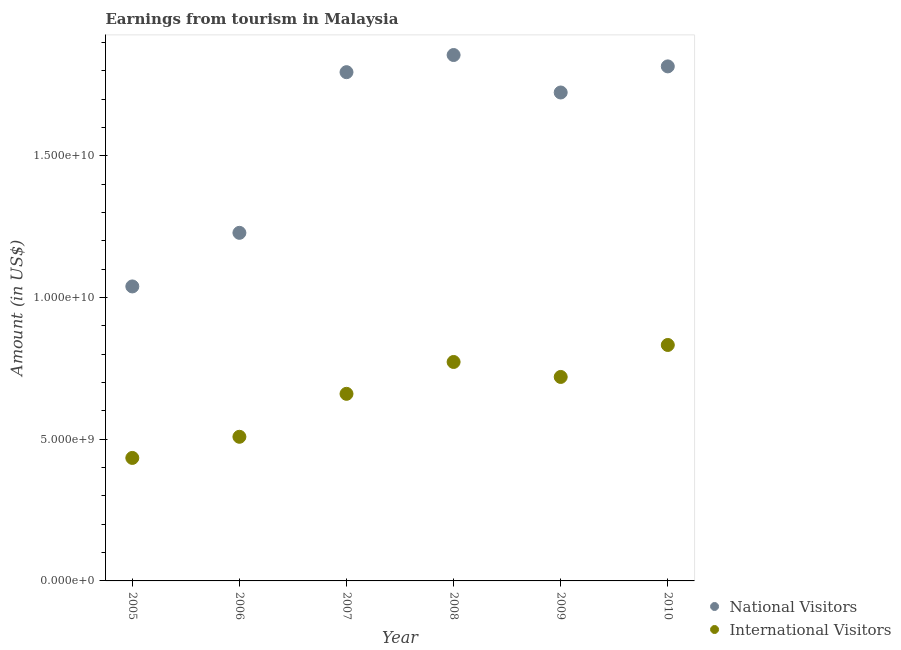How many different coloured dotlines are there?
Keep it short and to the point. 2. What is the amount earned from national visitors in 2007?
Your answer should be very brief. 1.79e+1. Across all years, what is the maximum amount earned from national visitors?
Your answer should be very brief. 1.86e+1. Across all years, what is the minimum amount earned from international visitors?
Offer a terse response. 4.34e+09. In which year was the amount earned from international visitors minimum?
Your answer should be very brief. 2005. What is the total amount earned from international visitors in the graph?
Your answer should be compact. 3.93e+1. What is the difference between the amount earned from international visitors in 2006 and that in 2009?
Provide a succinct answer. -2.11e+09. What is the difference between the amount earned from international visitors in 2007 and the amount earned from national visitors in 2009?
Your answer should be compact. -1.06e+1. What is the average amount earned from international visitors per year?
Offer a terse response. 6.54e+09. In the year 2010, what is the difference between the amount earned from international visitors and amount earned from national visitors?
Keep it short and to the point. -9.83e+09. In how many years, is the amount earned from international visitors greater than 14000000000 US$?
Make the answer very short. 0. What is the ratio of the amount earned from international visitors in 2005 to that in 2006?
Offer a very short reply. 0.85. Is the amount earned from international visitors in 2006 less than that in 2010?
Provide a succinct answer. Yes. What is the difference between the highest and the second highest amount earned from international visitors?
Your answer should be very brief. 6.00e+08. What is the difference between the highest and the lowest amount earned from national visitors?
Provide a succinct answer. 8.16e+09. In how many years, is the amount earned from international visitors greater than the average amount earned from international visitors taken over all years?
Offer a very short reply. 4. Is the sum of the amount earned from international visitors in 2005 and 2009 greater than the maximum amount earned from national visitors across all years?
Offer a terse response. No. Is the amount earned from international visitors strictly greater than the amount earned from national visitors over the years?
Make the answer very short. No. Is the amount earned from international visitors strictly less than the amount earned from national visitors over the years?
Your response must be concise. Yes. What is the difference between two consecutive major ticks on the Y-axis?
Your answer should be very brief. 5.00e+09. What is the title of the graph?
Offer a very short reply. Earnings from tourism in Malaysia. What is the label or title of the Y-axis?
Offer a terse response. Amount (in US$). What is the Amount (in US$) of National Visitors in 2005?
Your answer should be compact. 1.04e+1. What is the Amount (in US$) of International Visitors in 2005?
Offer a very short reply. 4.34e+09. What is the Amount (in US$) in National Visitors in 2006?
Offer a terse response. 1.23e+1. What is the Amount (in US$) in International Visitors in 2006?
Offer a terse response. 5.08e+09. What is the Amount (in US$) in National Visitors in 2007?
Your response must be concise. 1.79e+1. What is the Amount (in US$) of International Visitors in 2007?
Provide a short and direct response. 6.60e+09. What is the Amount (in US$) in National Visitors in 2008?
Give a very brief answer. 1.86e+1. What is the Amount (in US$) in International Visitors in 2008?
Give a very brief answer. 7.72e+09. What is the Amount (in US$) in National Visitors in 2009?
Offer a terse response. 1.72e+1. What is the Amount (in US$) in International Visitors in 2009?
Your answer should be compact. 7.20e+09. What is the Amount (in US$) of National Visitors in 2010?
Keep it short and to the point. 1.82e+1. What is the Amount (in US$) of International Visitors in 2010?
Ensure brevity in your answer.  8.32e+09. Across all years, what is the maximum Amount (in US$) in National Visitors?
Provide a short and direct response. 1.86e+1. Across all years, what is the maximum Amount (in US$) in International Visitors?
Your response must be concise. 8.32e+09. Across all years, what is the minimum Amount (in US$) in National Visitors?
Make the answer very short. 1.04e+1. Across all years, what is the minimum Amount (in US$) of International Visitors?
Ensure brevity in your answer.  4.34e+09. What is the total Amount (in US$) of National Visitors in the graph?
Offer a terse response. 9.46e+1. What is the total Amount (in US$) in International Visitors in the graph?
Give a very brief answer. 3.93e+1. What is the difference between the Amount (in US$) of National Visitors in 2005 and that in 2006?
Ensure brevity in your answer.  -1.89e+09. What is the difference between the Amount (in US$) in International Visitors in 2005 and that in 2006?
Make the answer very short. -7.46e+08. What is the difference between the Amount (in US$) in National Visitors in 2005 and that in 2007?
Provide a short and direct response. -7.56e+09. What is the difference between the Amount (in US$) in International Visitors in 2005 and that in 2007?
Offer a very short reply. -2.26e+09. What is the difference between the Amount (in US$) in National Visitors in 2005 and that in 2008?
Offer a very short reply. -8.16e+09. What is the difference between the Amount (in US$) of International Visitors in 2005 and that in 2008?
Keep it short and to the point. -3.38e+09. What is the difference between the Amount (in US$) of National Visitors in 2005 and that in 2009?
Provide a succinct answer. -6.84e+09. What is the difference between the Amount (in US$) of International Visitors in 2005 and that in 2009?
Offer a terse response. -2.86e+09. What is the difference between the Amount (in US$) in National Visitors in 2005 and that in 2010?
Your answer should be compact. -7.76e+09. What is the difference between the Amount (in US$) in International Visitors in 2005 and that in 2010?
Your response must be concise. -3.98e+09. What is the difference between the Amount (in US$) of National Visitors in 2006 and that in 2007?
Make the answer very short. -5.67e+09. What is the difference between the Amount (in US$) of International Visitors in 2006 and that in 2007?
Provide a succinct answer. -1.52e+09. What is the difference between the Amount (in US$) in National Visitors in 2006 and that in 2008?
Your response must be concise. -6.27e+09. What is the difference between the Amount (in US$) in International Visitors in 2006 and that in 2008?
Your answer should be compact. -2.64e+09. What is the difference between the Amount (in US$) of National Visitors in 2006 and that in 2009?
Provide a succinct answer. -4.95e+09. What is the difference between the Amount (in US$) in International Visitors in 2006 and that in 2009?
Your answer should be compact. -2.11e+09. What is the difference between the Amount (in US$) in National Visitors in 2006 and that in 2010?
Make the answer very short. -5.87e+09. What is the difference between the Amount (in US$) in International Visitors in 2006 and that in 2010?
Give a very brief answer. -3.24e+09. What is the difference between the Amount (in US$) in National Visitors in 2007 and that in 2008?
Make the answer very short. -6.05e+08. What is the difference between the Amount (in US$) in International Visitors in 2007 and that in 2008?
Provide a succinct answer. -1.12e+09. What is the difference between the Amount (in US$) of National Visitors in 2007 and that in 2009?
Make the answer very short. 7.17e+08. What is the difference between the Amount (in US$) of International Visitors in 2007 and that in 2009?
Make the answer very short. -5.96e+08. What is the difference between the Amount (in US$) of National Visitors in 2007 and that in 2010?
Provide a short and direct response. -2.04e+08. What is the difference between the Amount (in US$) in International Visitors in 2007 and that in 2010?
Keep it short and to the point. -1.72e+09. What is the difference between the Amount (in US$) of National Visitors in 2008 and that in 2009?
Offer a terse response. 1.32e+09. What is the difference between the Amount (in US$) in International Visitors in 2008 and that in 2009?
Offer a very short reply. 5.28e+08. What is the difference between the Amount (in US$) of National Visitors in 2008 and that in 2010?
Ensure brevity in your answer.  4.01e+08. What is the difference between the Amount (in US$) of International Visitors in 2008 and that in 2010?
Offer a very short reply. -6.00e+08. What is the difference between the Amount (in US$) of National Visitors in 2009 and that in 2010?
Offer a very short reply. -9.21e+08. What is the difference between the Amount (in US$) in International Visitors in 2009 and that in 2010?
Your answer should be very brief. -1.13e+09. What is the difference between the Amount (in US$) in National Visitors in 2005 and the Amount (in US$) in International Visitors in 2006?
Keep it short and to the point. 5.30e+09. What is the difference between the Amount (in US$) in National Visitors in 2005 and the Amount (in US$) in International Visitors in 2007?
Provide a succinct answer. 3.79e+09. What is the difference between the Amount (in US$) in National Visitors in 2005 and the Amount (in US$) in International Visitors in 2008?
Offer a very short reply. 2.66e+09. What is the difference between the Amount (in US$) in National Visitors in 2005 and the Amount (in US$) in International Visitors in 2009?
Provide a short and direct response. 3.19e+09. What is the difference between the Amount (in US$) of National Visitors in 2005 and the Amount (in US$) of International Visitors in 2010?
Give a very brief answer. 2.06e+09. What is the difference between the Amount (in US$) of National Visitors in 2006 and the Amount (in US$) of International Visitors in 2007?
Provide a succinct answer. 5.68e+09. What is the difference between the Amount (in US$) in National Visitors in 2006 and the Amount (in US$) in International Visitors in 2008?
Ensure brevity in your answer.  4.56e+09. What is the difference between the Amount (in US$) of National Visitors in 2006 and the Amount (in US$) of International Visitors in 2009?
Your answer should be very brief. 5.08e+09. What is the difference between the Amount (in US$) of National Visitors in 2006 and the Amount (in US$) of International Visitors in 2010?
Provide a succinct answer. 3.96e+09. What is the difference between the Amount (in US$) in National Visitors in 2007 and the Amount (in US$) in International Visitors in 2008?
Offer a terse response. 1.02e+1. What is the difference between the Amount (in US$) of National Visitors in 2007 and the Amount (in US$) of International Visitors in 2009?
Ensure brevity in your answer.  1.08e+1. What is the difference between the Amount (in US$) of National Visitors in 2007 and the Amount (in US$) of International Visitors in 2010?
Provide a short and direct response. 9.62e+09. What is the difference between the Amount (in US$) in National Visitors in 2008 and the Amount (in US$) in International Visitors in 2009?
Offer a terse response. 1.14e+1. What is the difference between the Amount (in US$) of National Visitors in 2008 and the Amount (in US$) of International Visitors in 2010?
Your answer should be very brief. 1.02e+1. What is the difference between the Amount (in US$) in National Visitors in 2009 and the Amount (in US$) in International Visitors in 2010?
Provide a short and direct response. 8.91e+09. What is the average Amount (in US$) of National Visitors per year?
Offer a terse response. 1.58e+1. What is the average Amount (in US$) of International Visitors per year?
Offer a terse response. 6.54e+09. In the year 2005, what is the difference between the Amount (in US$) of National Visitors and Amount (in US$) of International Visitors?
Give a very brief answer. 6.05e+09. In the year 2006, what is the difference between the Amount (in US$) of National Visitors and Amount (in US$) of International Visitors?
Offer a very short reply. 7.20e+09. In the year 2007, what is the difference between the Amount (in US$) of National Visitors and Amount (in US$) of International Visitors?
Give a very brief answer. 1.13e+1. In the year 2008, what is the difference between the Amount (in US$) of National Visitors and Amount (in US$) of International Visitors?
Your answer should be very brief. 1.08e+1. In the year 2009, what is the difference between the Amount (in US$) in National Visitors and Amount (in US$) in International Visitors?
Your answer should be very brief. 1.00e+1. In the year 2010, what is the difference between the Amount (in US$) in National Visitors and Amount (in US$) in International Visitors?
Your answer should be compact. 9.83e+09. What is the ratio of the Amount (in US$) of National Visitors in 2005 to that in 2006?
Offer a terse response. 0.85. What is the ratio of the Amount (in US$) of International Visitors in 2005 to that in 2006?
Provide a succinct answer. 0.85. What is the ratio of the Amount (in US$) of National Visitors in 2005 to that in 2007?
Offer a very short reply. 0.58. What is the ratio of the Amount (in US$) in International Visitors in 2005 to that in 2007?
Make the answer very short. 0.66. What is the ratio of the Amount (in US$) in National Visitors in 2005 to that in 2008?
Ensure brevity in your answer.  0.56. What is the ratio of the Amount (in US$) in International Visitors in 2005 to that in 2008?
Offer a terse response. 0.56. What is the ratio of the Amount (in US$) in National Visitors in 2005 to that in 2009?
Keep it short and to the point. 0.6. What is the ratio of the Amount (in US$) of International Visitors in 2005 to that in 2009?
Provide a succinct answer. 0.6. What is the ratio of the Amount (in US$) of National Visitors in 2005 to that in 2010?
Provide a succinct answer. 0.57. What is the ratio of the Amount (in US$) in International Visitors in 2005 to that in 2010?
Make the answer very short. 0.52. What is the ratio of the Amount (in US$) of National Visitors in 2006 to that in 2007?
Ensure brevity in your answer.  0.68. What is the ratio of the Amount (in US$) of International Visitors in 2006 to that in 2007?
Ensure brevity in your answer.  0.77. What is the ratio of the Amount (in US$) of National Visitors in 2006 to that in 2008?
Give a very brief answer. 0.66. What is the ratio of the Amount (in US$) in International Visitors in 2006 to that in 2008?
Ensure brevity in your answer.  0.66. What is the ratio of the Amount (in US$) in National Visitors in 2006 to that in 2009?
Your answer should be very brief. 0.71. What is the ratio of the Amount (in US$) in International Visitors in 2006 to that in 2009?
Your answer should be very brief. 0.71. What is the ratio of the Amount (in US$) in National Visitors in 2006 to that in 2010?
Your response must be concise. 0.68. What is the ratio of the Amount (in US$) of International Visitors in 2006 to that in 2010?
Ensure brevity in your answer.  0.61. What is the ratio of the Amount (in US$) in National Visitors in 2007 to that in 2008?
Your answer should be very brief. 0.97. What is the ratio of the Amount (in US$) in International Visitors in 2007 to that in 2008?
Make the answer very short. 0.85. What is the ratio of the Amount (in US$) of National Visitors in 2007 to that in 2009?
Ensure brevity in your answer.  1.04. What is the ratio of the Amount (in US$) of International Visitors in 2007 to that in 2009?
Offer a terse response. 0.92. What is the ratio of the Amount (in US$) in International Visitors in 2007 to that in 2010?
Your answer should be compact. 0.79. What is the ratio of the Amount (in US$) of National Visitors in 2008 to that in 2009?
Offer a very short reply. 1.08. What is the ratio of the Amount (in US$) of International Visitors in 2008 to that in 2009?
Make the answer very short. 1.07. What is the ratio of the Amount (in US$) in National Visitors in 2008 to that in 2010?
Your answer should be compact. 1.02. What is the ratio of the Amount (in US$) in International Visitors in 2008 to that in 2010?
Your answer should be compact. 0.93. What is the ratio of the Amount (in US$) of National Visitors in 2009 to that in 2010?
Ensure brevity in your answer.  0.95. What is the ratio of the Amount (in US$) of International Visitors in 2009 to that in 2010?
Give a very brief answer. 0.86. What is the difference between the highest and the second highest Amount (in US$) of National Visitors?
Your response must be concise. 4.01e+08. What is the difference between the highest and the second highest Amount (in US$) of International Visitors?
Offer a terse response. 6.00e+08. What is the difference between the highest and the lowest Amount (in US$) of National Visitors?
Offer a very short reply. 8.16e+09. What is the difference between the highest and the lowest Amount (in US$) in International Visitors?
Your answer should be very brief. 3.98e+09. 